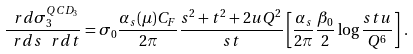<formula> <loc_0><loc_0><loc_500><loc_500>\frac { \ r d \sigma ^ { Q C D _ { 3 } } _ { 3 } } { \ r d s \, \ r d t } = \sigma _ { 0 } \frac { \alpha _ { s } ( \mu ) C _ { F } } { 2 \pi } \frac { s ^ { 2 } + t ^ { 2 } + 2 u Q ^ { 2 } } { s t } \left [ \frac { \alpha _ { s } } { 2 \pi } \frac { \beta _ { 0 } } { 2 } \log \frac { s t u } { Q ^ { 6 } } \right ] \, . \\</formula> 